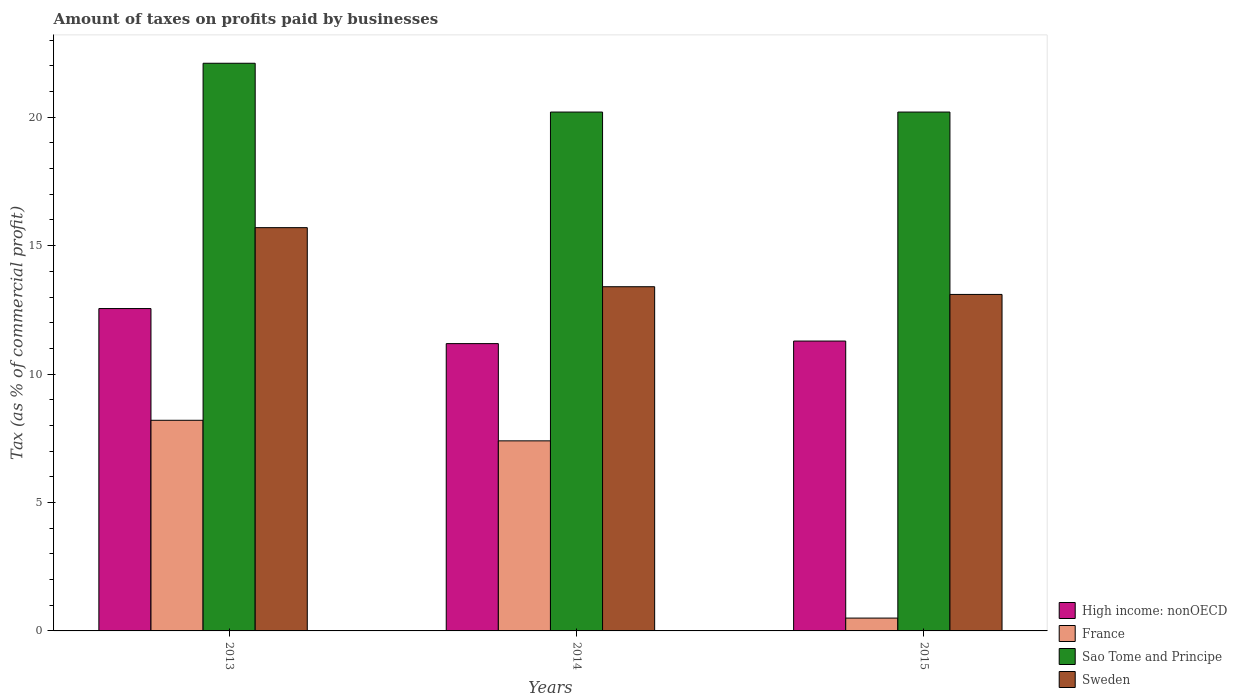What is the label of the 2nd group of bars from the left?
Your response must be concise. 2014. What is the percentage of taxes paid by businesses in France in 2014?
Ensure brevity in your answer.  7.4. Across all years, what is the maximum percentage of taxes paid by businesses in High income: nonOECD?
Provide a short and direct response. 12.55. Across all years, what is the minimum percentage of taxes paid by businesses in Sao Tome and Principe?
Make the answer very short. 20.2. In which year was the percentage of taxes paid by businesses in Sweden minimum?
Your response must be concise. 2015. What is the total percentage of taxes paid by businesses in Sweden in the graph?
Make the answer very short. 42.2. What is the difference between the percentage of taxes paid by businesses in France in 2013 and that in 2014?
Your response must be concise. 0.8. What is the average percentage of taxes paid by businesses in France per year?
Your answer should be very brief. 5.37. In the year 2013, what is the difference between the percentage of taxes paid by businesses in High income: nonOECD and percentage of taxes paid by businesses in France?
Give a very brief answer. 4.35. In how many years, is the percentage of taxes paid by businesses in Sao Tome and Principe greater than 7 %?
Your answer should be compact. 3. Is the difference between the percentage of taxes paid by businesses in High income: nonOECD in 2014 and 2015 greater than the difference between the percentage of taxes paid by businesses in France in 2014 and 2015?
Keep it short and to the point. No. What is the difference between the highest and the second highest percentage of taxes paid by businesses in France?
Offer a terse response. 0.8. What is the difference between the highest and the lowest percentage of taxes paid by businesses in Sweden?
Your response must be concise. 2.6. In how many years, is the percentage of taxes paid by businesses in Sao Tome and Principe greater than the average percentage of taxes paid by businesses in Sao Tome and Principe taken over all years?
Give a very brief answer. 1. Is it the case that in every year, the sum of the percentage of taxes paid by businesses in High income: nonOECD and percentage of taxes paid by businesses in Sweden is greater than the sum of percentage of taxes paid by businesses in France and percentage of taxes paid by businesses in Sao Tome and Principe?
Offer a very short reply. Yes. How many years are there in the graph?
Keep it short and to the point. 3. What is the difference between two consecutive major ticks on the Y-axis?
Your answer should be very brief. 5. Does the graph contain grids?
Provide a succinct answer. No. Where does the legend appear in the graph?
Your response must be concise. Bottom right. How are the legend labels stacked?
Your answer should be very brief. Vertical. What is the title of the graph?
Keep it short and to the point. Amount of taxes on profits paid by businesses. Does "Equatorial Guinea" appear as one of the legend labels in the graph?
Give a very brief answer. No. What is the label or title of the Y-axis?
Offer a terse response. Tax (as % of commercial profit). What is the Tax (as % of commercial profit) of High income: nonOECD in 2013?
Your answer should be compact. 12.55. What is the Tax (as % of commercial profit) of Sao Tome and Principe in 2013?
Provide a short and direct response. 22.1. What is the Tax (as % of commercial profit) of High income: nonOECD in 2014?
Your answer should be very brief. 11.19. What is the Tax (as % of commercial profit) of France in 2014?
Provide a short and direct response. 7.4. What is the Tax (as % of commercial profit) of Sao Tome and Principe in 2014?
Your response must be concise. 20.2. What is the Tax (as % of commercial profit) in High income: nonOECD in 2015?
Keep it short and to the point. 11.29. What is the Tax (as % of commercial profit) in France in 2015?
Make the answer very short. 0.5. What is the Tax (as % of commercial profit) in Sao Tome and Principe in 2015?
Ensure brevity in your answer.  20.2. Across all years, what is the maximum Tax (as % of commercial profit) in High income: nonOECD?
Offer a terse response. 12.55. Across all years, what is the maximum Tax (as % of commercial profit) in Sao Tome and Principe?
Offer a very short reply. 22.1. Across all years, what is the maximum Tax (as % of commercial profit) of Sweden?
Give a very brief answer. 15.7. Across all years, what is the minimum Tax (as % of commercial profit) of High income: nonOECD?
Provide a succinct answer. 11.19. Across all years, what is the minimum Tax (as % of commercial profit) of France?
Your response must be concise. 0.5. Across all years, what is the minimum Tax (as % of commercial profit) in Sao Tome and Principe?
Make the answer very short. 20.2. What is the total Tax (as % of commercial profit) of High income: nonOECD in the graph?
Ensure brevity in your answer.  35.02. What is the total Tax (as % of commercial profit) of France in the graph?
Your answer should be compact. 16.1. What is the total Tax (as % of commercial profit) of Sao Tome and Principe in the graph?
Your answer should be compact. 62.5. What is the total Tax (as % of commercial profit) of Sweden in the graph?
Make the answer very short. 42.2. What is the difference between the Tax (as % of commercial profit) of High income: nonOECD in 2013 and that in 2014?
Provide a short and direct response. 1.36. What is the difference between the Tax (as % of commercial profit) in France in 2013 and that in 2014?
Your answer should be compact. 0.8. What is the difference between the Tax (as % of commercial profit) in Sao Tome and Principe in 2013 and that in 2014?
Your answer should be very brief. 1.9. What is the difference between the Tax (as % of commercial profit) of Sweden in 2013 and that in 2014?
Your answer should be very brief. 2.3. What is the difference between the Tax (as % of commercial profit) of High income: nonOECD in 2013 and that in 2015?
Your answer should be compact. 1.26. What is the difference between the Tax (as % of commercial profit) in France in 2013 and that in 2015?
Make the answer very short. 7.7. What is the difference between the Tax (as % of commercial profit) of Sao Tome and Principe in 2013 and that in 2015?
Provide a succinct answer. 1.9. What is the difference between the Tax (as % of commercial profit) of Sweden in 2013 and that in 2015?
Offer a very short reply. 2.6. What is the difference between the Tax (as % of commercial profit) of Sao Tome and Principe in 2014 and that in 2015?
Offer a very short reply. 0. What is the difference between the Tax (as % of commercial profit) in Sweden in 2014 and that in 2015?
Ensure brevity in your answer.  0.3. What is the difference between the Tax (as % of commercial profit) in High income: nonOECD in 2013 and the Tax (as % of commercial profit) in France in 2014?
Provide a short and direct response. 5.15. What is the difference between the Tax (as % of commercial profit) of High income: nonOECD in 2013 and the Tax (as % of commercial profit) of Sao Tome and Principe in 2014?
Give a very brief answer. -7.65. What is the difference between the Tax (as % of commercial profit) of High income: nonOECD in 2013 and the Tax (as % of commercial profit) of Sweden in 2014?
Offer a very short reply. -0.85. What is the difference between the Tax (as % of commercial profit) of France in 2013 and the Tax (as % of commercial profit) of Sweden in 2014?
Ensure brevity in your answer.  -5.2. What is the difference between the Tax (as % of commercial profit) in Sao Tome and Principe in 2013 and the Tax (as % of commercial profit) in Sweden in 2014?
Ensure brevity in your answer.  8.7. What is the difference between the Tax (as % of commercial profit) of High income: nonOECD in 2013 and the Tax (as % of commercial profit) of France in 2015?
Provide a succinct answer. 12.05. What is the difference between the Tax (as % of commercial profit) of High income: nonOECD in 2013 and the Tax (as % of commercial profit) of Sao Tome and Principe in 2015?
Give a very brief answer. -7.65. What is the difference between the Tax (as % of commercial profit) of High income: nonOECD in 2013 and the Tax (as % of commercial profit) of Sweden in 2015?
Your response must be concise. -0.55. What is the difference between the Tax (as % of commercial profit) of France in 2013 and the Tax (as % of commercial profit) of Sao Tome and Principe in 2015?
Provide a short and direct response. -12. What is the difference between the Tax (as % of commercial profit) in France in 2013 and the Tax (as % of commercial profit) in Sweden in 2015?
Offer a very short reply. -4.9. What is the difference between the Tax (as % of commercial profit) of High income: nonOECD in 2014 and the Tax (as % of commercial profit) of France in 2015?
Provide a short and direct response. 10.69. What is the difference between the Tax (as % of commercial profit) of High income: nonOECD in 2014 and the Tax (as % of commercial profit) of Sao Tome and Principe in 2015?
Provide a succinct answer. -9.01. What is the difference between the Tax (as % of commercial profit) of High income: nonOECD in 2014 and the Tax (as % of commercial profit) of Sweden in 2015?
Your answer should be very brief. -1.91. What is the difference between the Tax (as % of commercial profit) in France in 2014 and the Tax (as % of commercial profit) in Sao Tome and Principe in 2015?
Offer a terse response. -12.8. What is the difference between the Tax (as % of commercial profit) in France in 2014 and the Tax (as % of commercial profit) in Sweden in 2015?
Offer a very short reply. -5.7. What is the average Tax (as % of commercial profit) of High income: nonOECD per year?
Offer a terse response. 11.67. What is the average Tax (as % of commercial profit) in France per year?
Provide a short and direct response. 5.37. What is the average Tax (as % of commercial profit) of Sao Tome and Principe per year?
Offer a very short reply. 20.83. What is the average Tax (as % of commercial profit) in Sweden per year?
Offer a terse response. 14.07. In the year 2013, what is the difference between the Tax (as % of commercial profit) in High income: nonOECD and Tax (as % of commercial profit) in France?
Your answer should be very brief. 4.35. In the year 2013, what is the difference between the Tax (as % of commercial profit) in High income: nonOECD and Tax (as % of commercial profit) in Sao Tome and Principe?
Provide a succinct answer. -9.55. In the year 2013, what is the difference between the Tax (as % of commercial profit) of High income: nonOECD and Tax (as % of commercial profit) of Sweden?
Your answer should be compact. -3.15. In the year 2013, what is the difference between the Tax (as % of commercial profit) of France and Tax (as % of commercial profit) of Sao Tome and Principe?
Give a very brief answer. -13.9. In the year 2013, what is the difference between the Tax (as % of commercial profit) in Sao Tome and Principe and Tax (as % of commercial profit) in Sweden?
Make the answer very short. 6.4. In the year 2014, what is the difference between the Tax (as % of commercial profit) of High income: nonOECD and Tax (as % of commercial profit) of France?
Provide a succinct answer. 3.79. In the year 2014, what is the difference between the Tax (as % of commercial profit) in High income: nonOECD and Tax (as % of commercial profit) in Sao Tome and Principe?
Ensure brevity in your answer.  -9.01. In the year 2014, what is the difference between the Tax (as % of commercial profit) in High income: nonOECD and Tax (as % of commercial profit) in Sweden?
Your answer should be very brief. -2.21. In the year 2014, what is the difference between the Tax (as % of commercial profit) in Sao Tome and Principe and Tax (as % of commercial profit) in Sweden?
Make the answer very short. 6.8. In the year 2015, what is the difference between the Tax (as % of commercial profit) of High income: nonOECD and Tax (as % of commercial profit) of France?
Keep it short and to the point. 10.79. In the year 2015, what is the difference between the Tax (as % of commercial profit) in High income: nonOECD and Tax (as % of commercial profit) in Sao Tome and Principe?
Your answer should be very brief. -8.91. In the year 2015, what is the difference between the Tax (as % of commercial profit) in High income: nonOECD and Tax (as % of commercial profit) in Sweden?
Offer a terse response. -1.81. In the year 2015, what is the difference between the Tax (as % of commercial profit) of France and Tax (as % of commercial profit) of Sao Tome and Principe?
Make the answer very short. -19.7. In the year 2015, what is the difference between the Tax (as % of commercial profit) of France and Tax (as % of commercial profit) of Sweden?
Offer a terse response. -12.6. In the year 2015, what is the difference between the Tax (as % of commercial profit) in Sao Tome and Principe and Tax (as % of commercial profit) in Sweden?
Ensure brevity in your answer.  7.1. What is the ratio of the Tax (as % of commercial profit) in High income: nonOECD in 2013 to that in 2014?
Your answer should be very brief. 1.12. What is the ratio of the Tax (as % of commercial profit) of France in 2013 to that in 2014?
Make the answer very short. 1.11. What is the ratio of the Tax (as % of commercial profit) in Sao Tome and Principe in 2013 to that in 2014?
Offer a terse response. 1.09. What is the ratio of the Tax (as % of commercial profit) of Sweden in 2013 to that in 2014?
Make the answer very short. 1.17. What is the ratio of the Tax (as % of commercial profit) in High income: nonOECD in 2013 to that in 2015?
Ensure brevity in your answer.  1.11. What is the ratio of the Tax (as % of commercial profit) of Sao Tome and Principe in 2013 to that in 2015?
Keep it short and to the point. 1.09. What is the ratio of the Tax (as % of commercial profit) of Sweden in 2013 to that in 2015?
Make the answer very short. 1.2. What is the ratio of the Tax (as % of commercial profit) of France in 2014 to that in 2015?
Make the answer very short. 14.8. What is the ratio of the Tax (as % of commercial profit) in Sweden in 2014 to that in 2015?
Provide a succinct answer. 1.02. What is the difference between the highest and the second highest Tax (as % of commercial profit) in High income: nonOECD?
Provide a short and direct response. 1.26. What is the difference between the highest and the second highest Tax (as % of commercial profit) of France?
Your response must be concise. 0.8. What is the difference between the highest and the lowest Tax (as % of commercial profit) in High income: nonOECD?
Your answer should be very brief. 1.36. What is the difference between the highest and the lowest Tax (as % of commercial profit) in Sweden?
Keep it short and to the point. 2.6. 